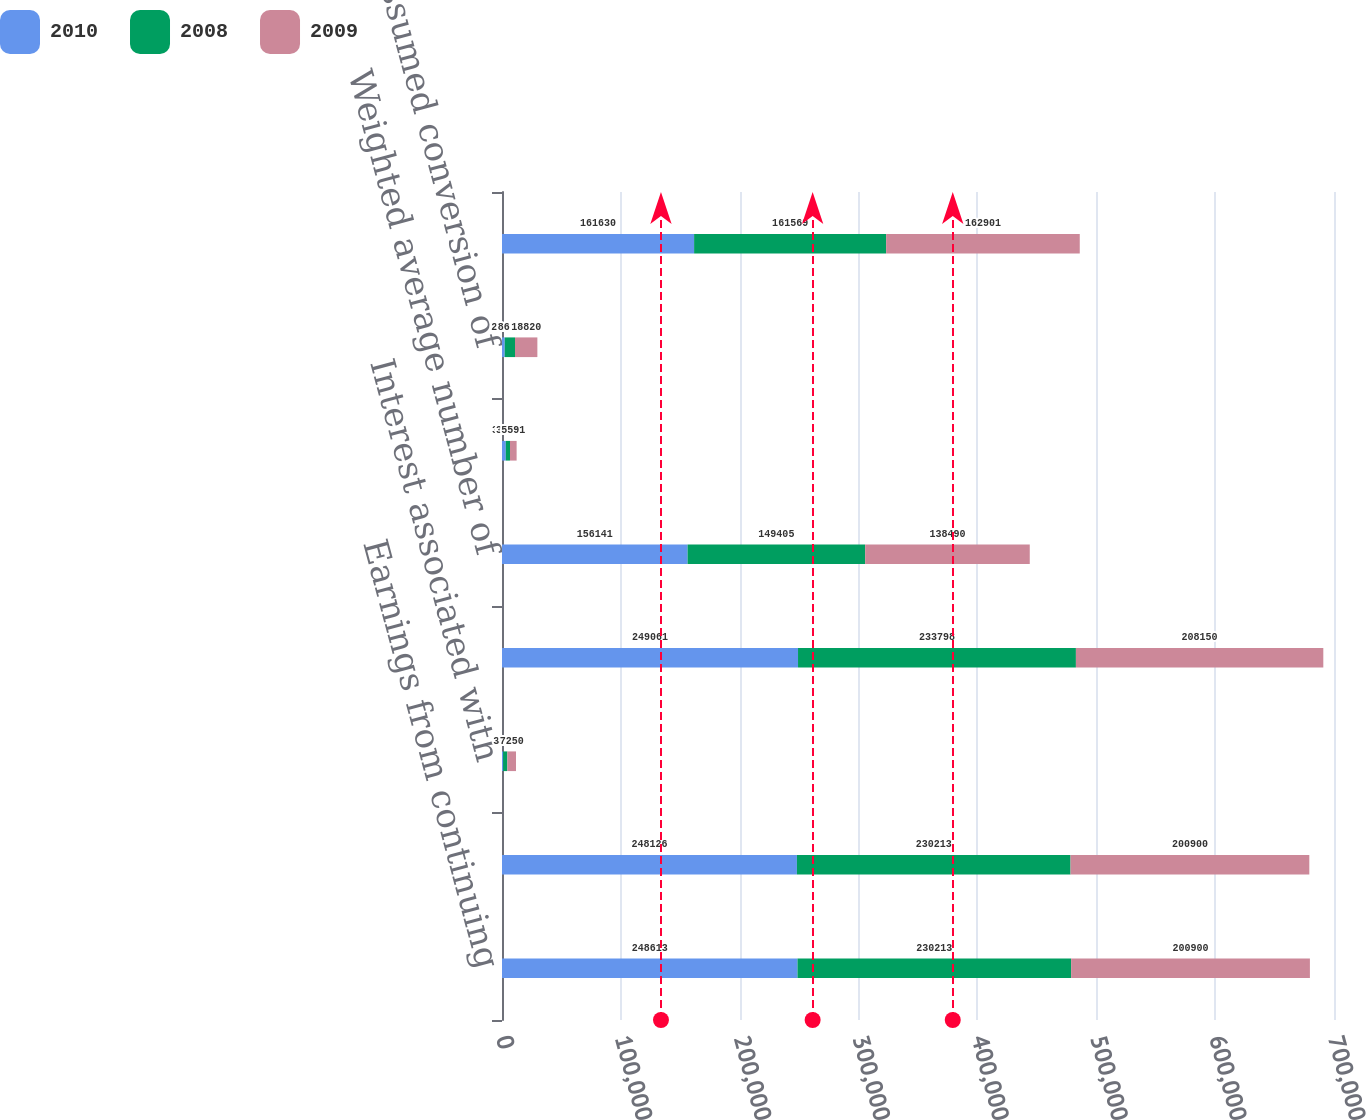<chart> <loc_0><loc_0><loc_500><loc_500><stacked_bar_chart><ecel><fcel>Earnings from continuing<fcel>Net earnings for basic<fcel>Interest associated with<fcel>Net earnings available to<fcel>Weighted average number of<fcel>Assumed exercise of stock<fcel>Assumed conversion of<fcel>Diluted shares outstanding<nl><fcel>2010<fcel>248613<fcel>248126<fcel>935<fcel>249061<fcel>156141<fcel>3196<fcel>2293<fcel>161630<nl><fcel>2008<fcel>230213<fcel>230213<fcel>3585<fcel>233798<fcel>149405<fcel>3518<fcel>8646<fcel>161569<nl><fcel>2009<fcel>200900<fcel>200900<fcel>7250<fcel>208150<fcel>138490<fcel>5591<fcel>18820<fcel>162901<nl></chart> 